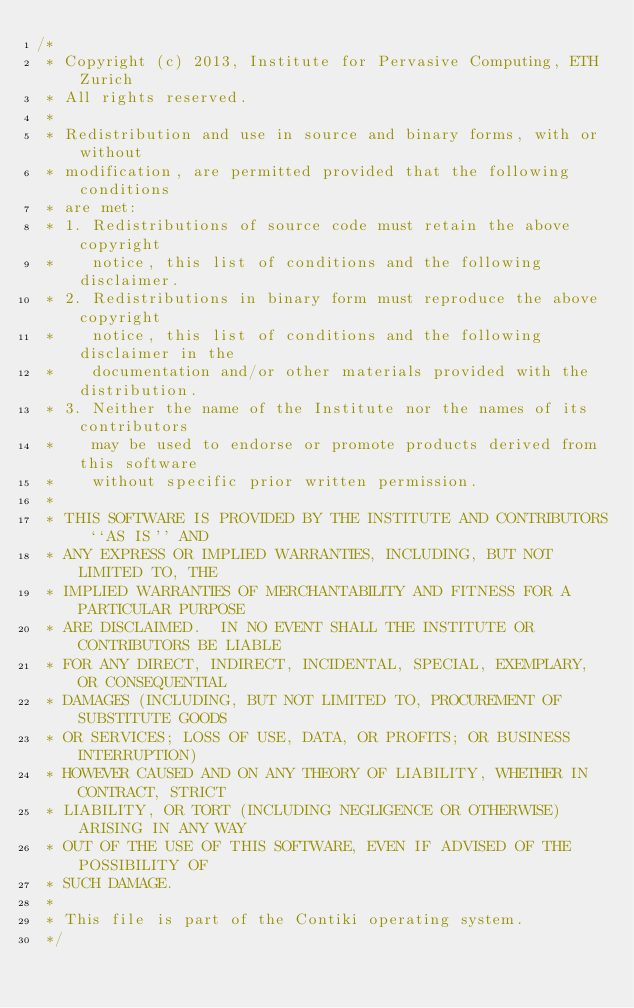Convert code to text. <code><loc_0><loc_0><loc_500><loc_500><_C_>/*
 * Copyright (c) 2013, Institute for Pervasive Computing, ETH Zurich
 * All rights reserved.
 *
 * Redistribution and use in source and binary forms, with or without
 * modification, are permitted provided that the following conditions
 * are met:
 * 1. Redistributions of source code must retain the above copyright
 *    notice, this list of conditions and the following disclaimer.
 * 2. Redistributions in binary form must reproduce the above copyright
 *    notice, this list of conditions and the following disclaimer in the
 *    documentation and/or other materials provided with the distribution.
 * 3. Neither the name of the Institute nor the names of its contributors
 *    may be used to endorse or promote products derived from this software
 *    without specific prior written permission.
 *
 * THIS SOFTWARE IS PROVIDED BY THE INSTITUTE AND CONTRIBUTORS ``AS IS'' AND
 * ANY EXPRESS OR IMPLIED WARRANTIES, INCLUDING, BUT NOT LIMITED TO, THE
 * IMPLIED WARRANTIES OF MERCHANTABILITY AND FITNESS FOR A PARTICULAR PURPOSE
 * ARE DISCLAIMED.  IN NO EVENT SHALL THE INSTITUTE OR CONTRIBUTORS BE LIABLE
 * FOR ANY DIRECT, INDIRECT, INCIDENTAL, SPECIAL, EXEMPLARY, OR CONSEQUENTIAL
 * DAMAGES (INCLUDING, BUT NOT LIMITED TO, PROCUREMENT OF SUBSTITUTE GOODS
 * OR SERVICES; LOSS OF USE, DATA, OR PROFITS; OR BUSINESS INTERRUPTION)
 * HOWEVER CAUSED AND ON ANY THEORY OF LIABILITY, WHETHER IN CONTRACT, STRICT
 * LIABILITY, OR TORT (INCLUDING NEGLIGENCE OR OTHERWISE) ARISING IN ANY WAY
 * OUT OF THE USE OF THIS SOFTWARE, EVEN IF ADVISED OF THE POSSIBILITY OF
 * SUCH DAMAGE.
 *
 * This file is part of the Contiki operating system.
 */
</code> 